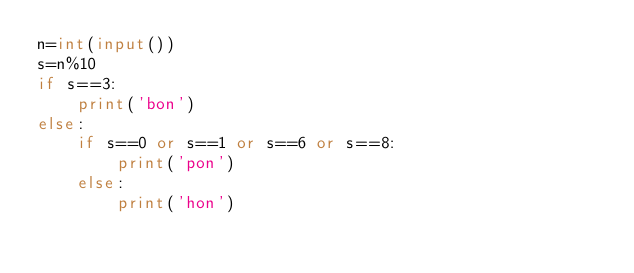Convert code to text. <code><loc_0><loc_0><loc_500><loc_500><_Python_>n=int(input())
s=n%10
if s==3:
    print('bon')
else:
    if s==0 or s==1 or s==6 or s==8:
        print('pon')
    else:
        print('hon')</code> 